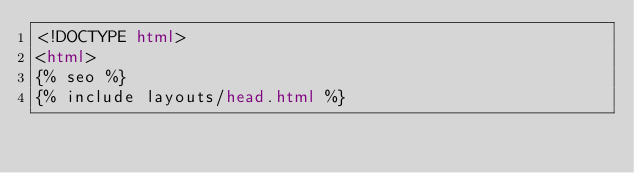Convert code to text. <code><loc_0><loc_0><loc_500><loc_500><_HTML_><!DOCTYPE html>
<html>
{% seo %}
{% include layouts/head.html %}
</code> 